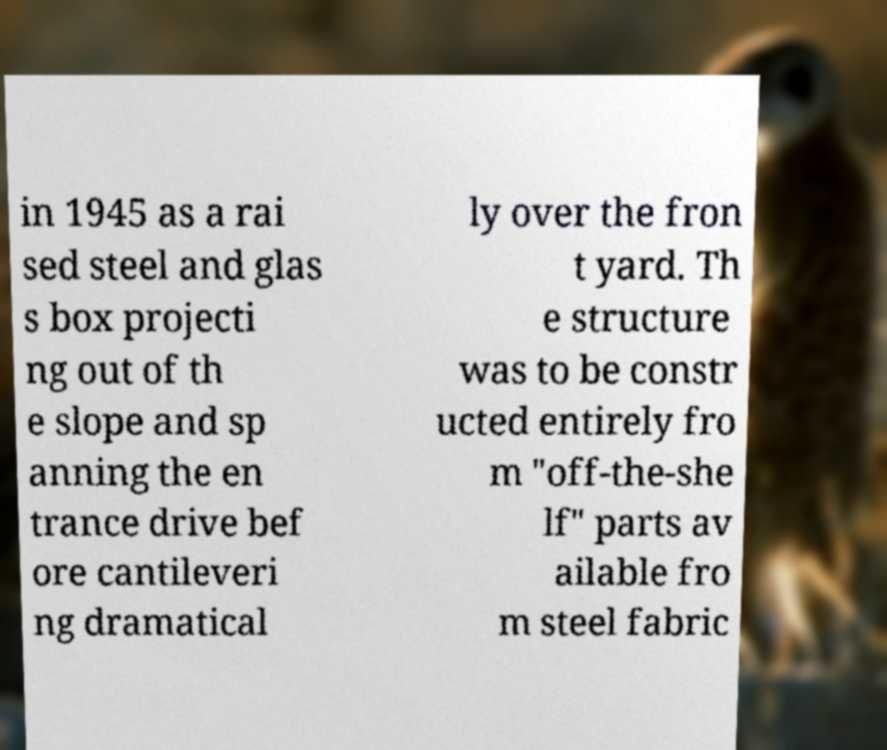Could you assist in decoding the text presented in this image and type it out clearly? in 1945 as a rai sed steel and glas s box projecti ng out of th e slope and sp anning the en trance drive bef ore cantileveri ng dramatical ly over the fron t yard. Th e structure was to be constr ucted entirely fro m "off-the-she lf" parts av ailable fro m steel fabric 